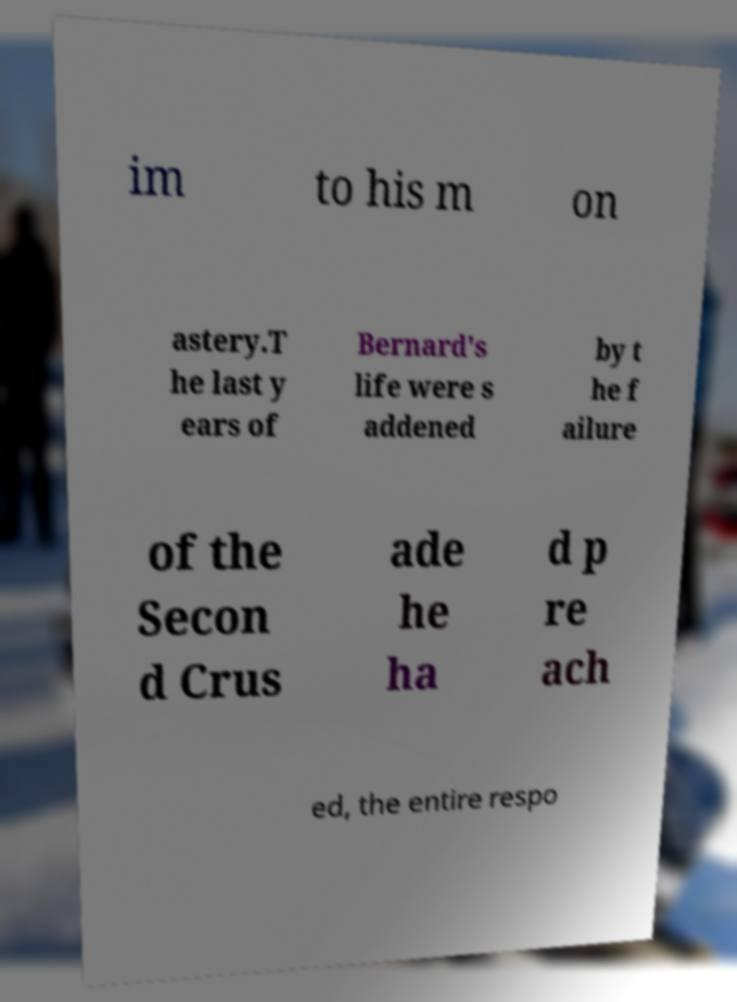Can you accurately transcribe the text from the provided image for me? im to his m on astery.T he last y ears of Bernard's life were s addened by t he f ailure of the Secon d Crus ade he ha d p re ach ed, the entire respo 